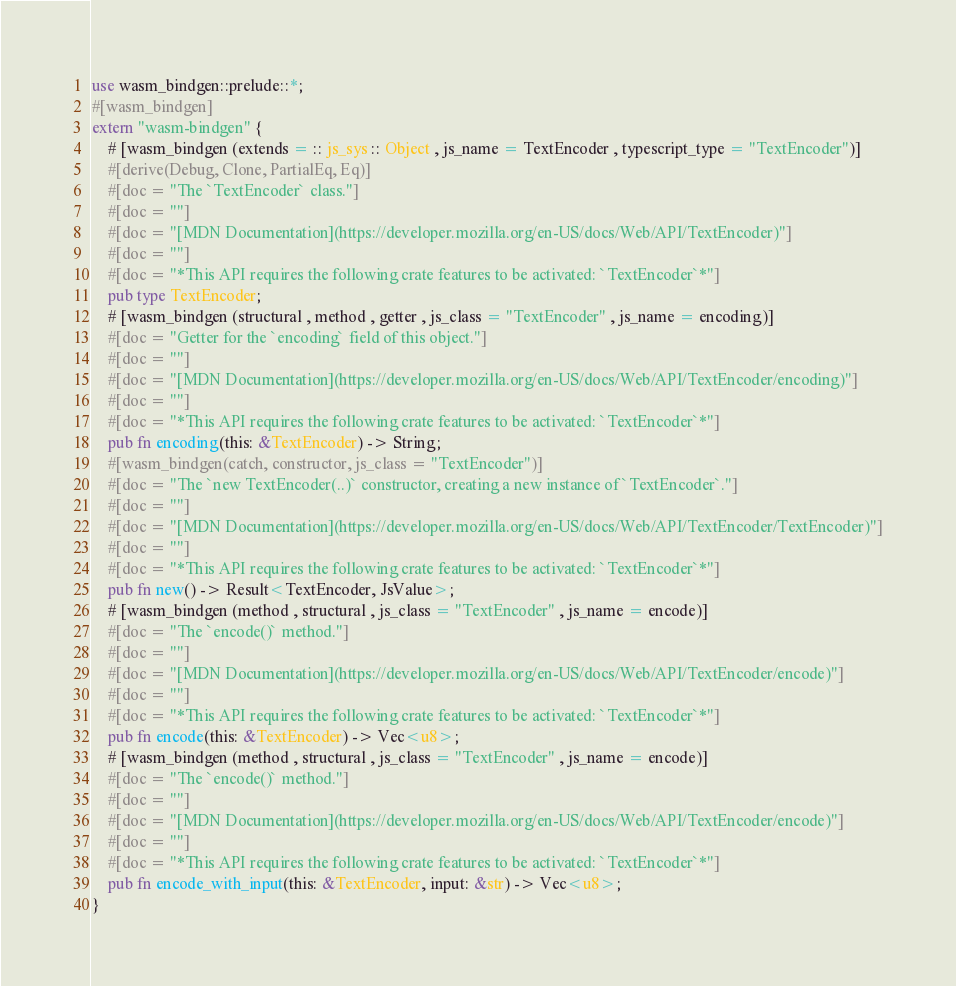Convert code to text. <code><loc_0><loc_0><loc_500><loc_500><_Rust_>use wasm_bindgen::prelude::*;
#[wasm_bindgen]
extern "wasm-bindgen" {
    # [wasm_bindgen (extends = :: js_sys :: Object , js_name = TextEncoder , typescript_type = "TextEncoder")]
    #[derive(Debug, Clone, PartialEq, Eq)]
    #[doc = "The `TextEncoder` class."]
    #[doc = ""]
    #[doc = "[MDN Documentation](https://developer.mozilla.org/en-US/docs/Web/API/TextEncoder)"]
    #[doc = ""]
    #[doc = "*This API requires the following crate features to be activated: `TextEncoder`*"]
    pub type TextEncoder;
    # [wasm_bindgen (structural , method , getter , js_class = "TextEncoder" , js_name = encoding)]
    #[doc = "Getter for the `encoding` field of this object."]
    #[doc = ""]
    #[doc = "[MDN Documentation](https://developer.mozilla.org/en-US/docs/Web/API/TextEncoder/encoding)"]
    #[doc = ""]
    #[doc = "*This API requires the following crate features to be activated: `TextEncoder`*"]
    pub fn encoding(this: &TextEncoder) -> String;
    #[wasm_bindgen(catch, constructor, js_class = "TextEncoder")]
    #[doc = "The `new TextEncoder(..)` constructor, creating a new instance of `TextEncoder`."]
    #[doc = ""]
    #[doc = "[MDN Documentation](https://developer.mozilla.org/en-US/docs/Web/API/TextEncoder/TextEncoder)"]
    #[doc = ""]
    #[doc = "*This API requires the following crate features to be activated: `TextEncoder`*"]
    pub fn new() -> Result<TextEncoder, JsValue>;
    # [wasm_bindgen (method , structural , js_class = "TextEncoder" , js_name = encode)]
    #[doc = "The `encode()` method."]
    #[doc = ""]
    #[doc = "[MDN Documentation](https://developer.mozilla.org/en-US/docs/Web/API/TextEncoder/encode)"]
    #[doc = ""]
    #[doc = "*This API requires the following crate features to be activated: `TextEncoder`*"]
    pub fn encode(this: &TextEncoder) -> Vec<u8>;
    # [wasm_bindgen (method , structural , js_class = "TextEncoder" , js_name = encode)]
    #[doc = "The `encode()` method."]
    #[doc = ""]
    #[doc = "[MDN Documentation](https://developer.mozilla.org/en-US/docs/Web/API/TextEncoder/encode)"]
    #[doc = ""]
    #[doc = "*This API requires the following crate features to be activated: `TextEncoder`*"]
    pub fn encode_with_input(this: &TextEncoder, input: &str) -> Vec<u8>;
}
</code> 